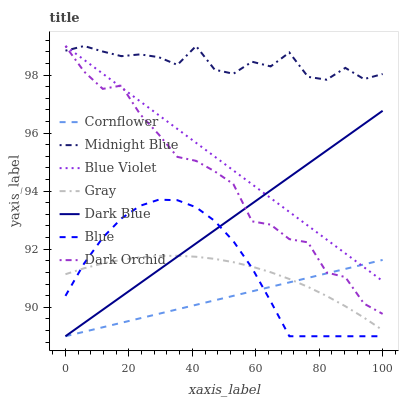Does Cornflower have the minimum area under the curve?
Answer yes or no. Yes. Does Midnight Blue have the maximum area under the curve?
Answer yes or no. Yes. Does Midnight Blue have the minimum area under the curve?
Answer yes or no. No. Does Cornflower have the maximum area under the curve?
Answer yes or no. No. Is Cornflower the smoothest?
Answer yes or no. Yes. Is Midnight Blue the roughest?
Answer yes or no. Yes. Is Midnight Blue the smoothest?
Answer yes or no. No. Is Cornflower the roughest?
Answer yes or no. No. Does Blue have the lowest value?
Answer yes or no. Yes. Does Midnight Blue have the lowest value?
Answer yes or no. No. Does Blue Violet have the highest value?
Answer yes or no. Yes. Does Cornflower have the highest value?
Answer yes or no. No. Is Gray less than Dark Orchid?
Answer yes or no. Yes. Is Midnight Blue greater than Cornflower?
Answer yes or no. Yes. Does Blue intersect Cornflower?
Answer yes or no. Yes. Is Blue less than Cornflower?
Answer yes or no. No. Is Blue greater than Cornflower?
Answer yes or no. No. Does Gray intersect Dark Orchid?
Answer yes or no. No. 